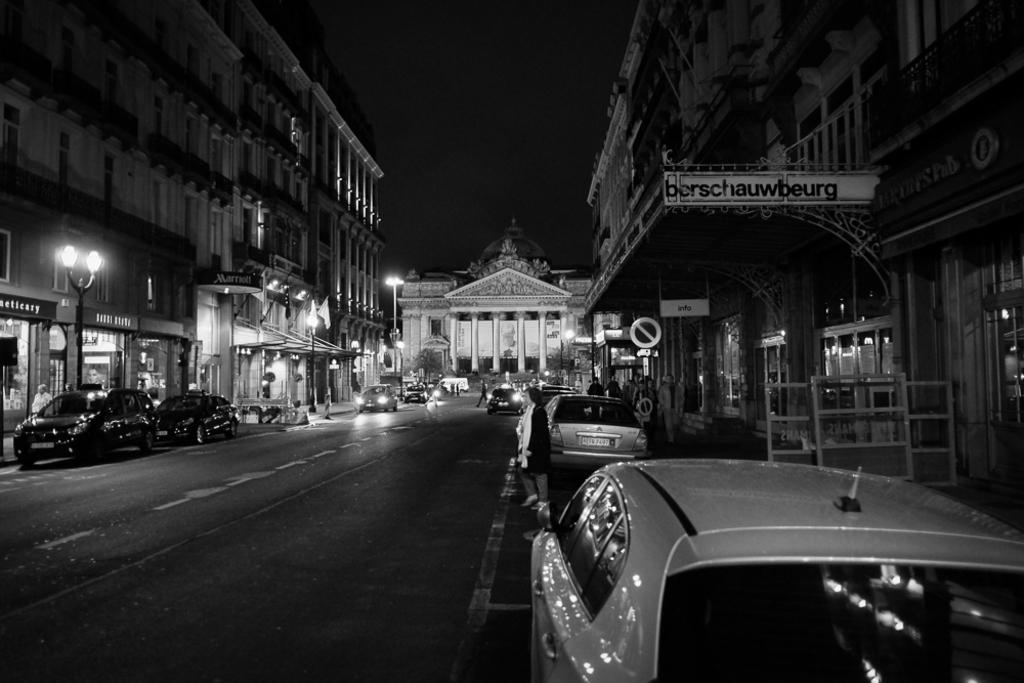What can be seen on the road in the image? There are cars parked on the road in the image. What are the people in the image doing? Several persons are walking on the path in the image. What can be seen in the background of the image? There are buildings, poles, lights, and the sky visible in the background of the image. What type of fan can be seen in the image? There is no fan present in the image. How does the behavior of the cars parked on the road affect the pedestrians in the image? The parked cars do not affect the behavior of the pedestrians in the image, as they are not moving. 